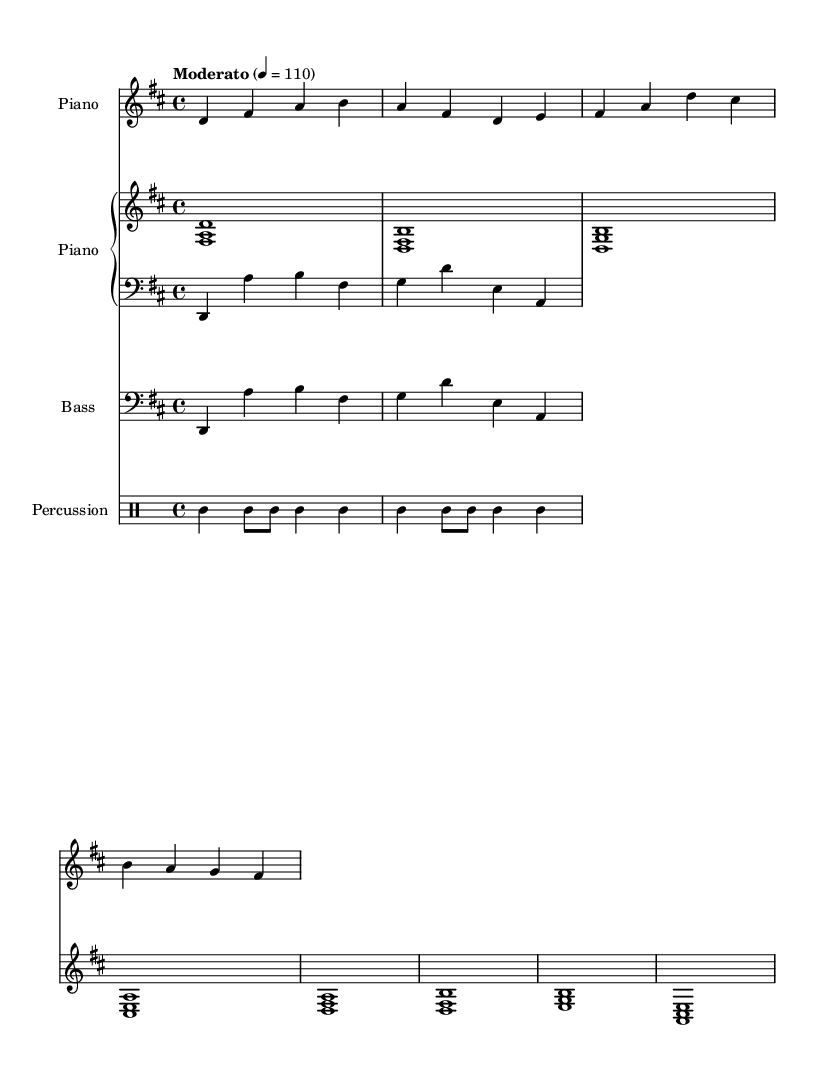What is the key signature of this music? The key signature is indicated on the staff, showing two sharps. This corresponds to D major, which has the notes F# and C#.
Answer: D major What is the time signature of this music? The time signature is indicated by the numbers at the beginning of the sheet music, which shows 4 on the top and 4 on the bottom. This means there are four beats in each measure, and a quarter note receives one beat.
Answer: 4/4 What tempo marking is specified for this piece? The tempo marking is located at the beginning of the score, indicating "Moderato" with a metronome marking of 110. This sets the expected speed for the performance.
Answer: Moderato 4 = 110 How many measures are in the melody line? The melody line contains a total of 8 measures, as counted in the section under the treble clef. Each section separated by vertical lines indicates the end of a measure.
Answer: 8 measures What instruments are featured in this composition? The composition includes a staff labeled "Piano" and an additional staff labeled "Bass," along with a "Percussion" staff. This specifies the types of instruments used in the piece.
Answer: Piano, Bass, Percussion What type of musical style does this sheet music suggest? Considering the Afro-Latin fusion elements present in the rhythmic patterns and melodic structure, this music combines influences from Afro-Cuban and Latin music styles for a relaxing feel.
Answer: Afro-Latin fusion 